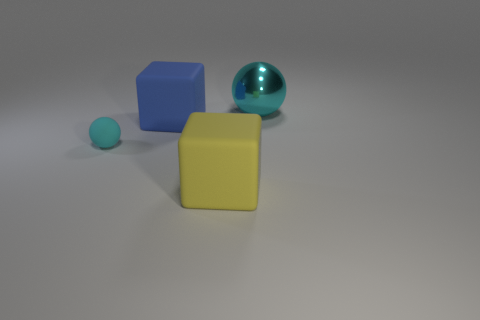Add 4 big yellow things. How many objects exist? 8 Subtract all small rubber balls. Subtract all matte blocks. How many objects are left? 1 Add 1 tiny spheres. How many tiny spheres are left? 2 Add 3 blue metal cylinders. How many blue metal cylinders exist? 3 Subtract 0 purple cylinders. How many objects are left? 4 